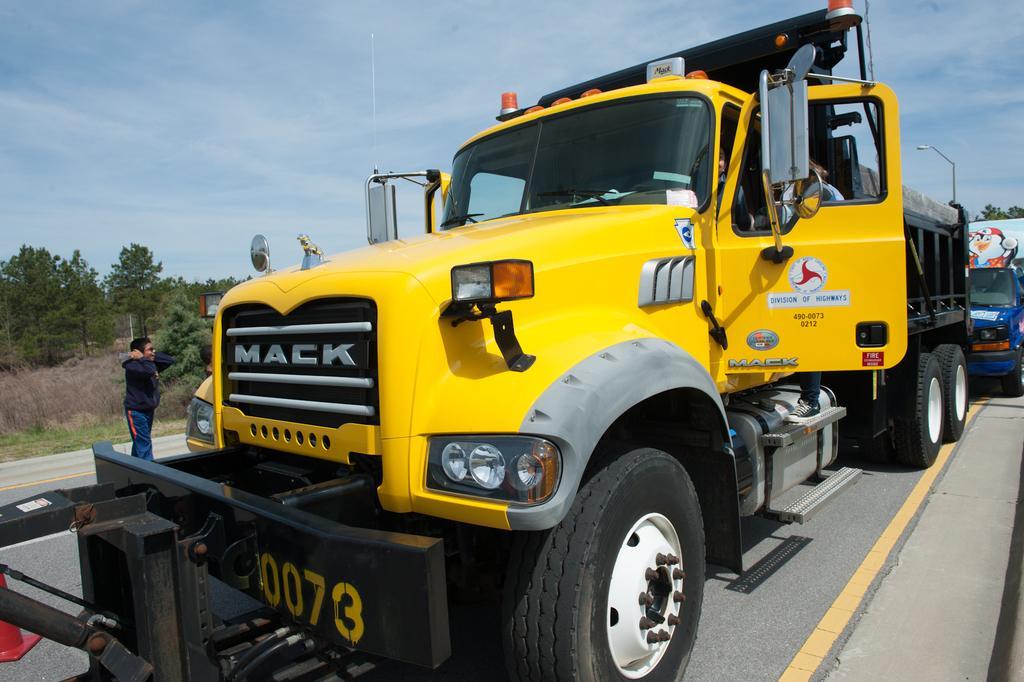Describe this image in one or two sentences. In this picture, we can see a few vehicles on the road, and we can see a few people in the vehicle and a person on the road, we can see the ground with grass, plants, dry grass, trees, light pole, and we can see the sky with clouds. 